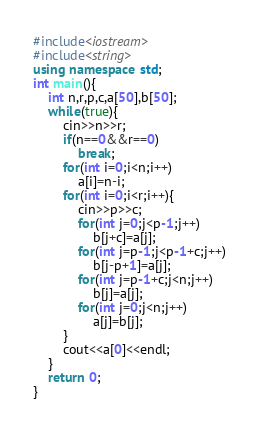Convert code to text. <code><loc_0><loc_0><loc_500><loc_500><_C++_>#include<iostream>
#include<string>
using namespace std;
int main(){
	int n,r,p,c,a[50],b[50];
	while(true){
		cin>>n>>r;
		if(n==0&&r==0)
			break;
		for(int i=0;i<n;i++)
			a[i]=n-i;
		for(int i=0;i<r;i++){
			cin>>p>>c;
			for(int j=0;j<p-1;j++)
				b[j+c]=a[j];
			for(int j=p-1;j<p-1+c;j++)
				b[j-p+1]=a[j];
			for(int j=p-1+c;j<n;j++)
				b[j]=a[j];
			for(int j=0;j<n;j++)
				a[j]=b[j];
		}
		cout<<a[0]<<endl;
	}
    return 0;
}</code> 